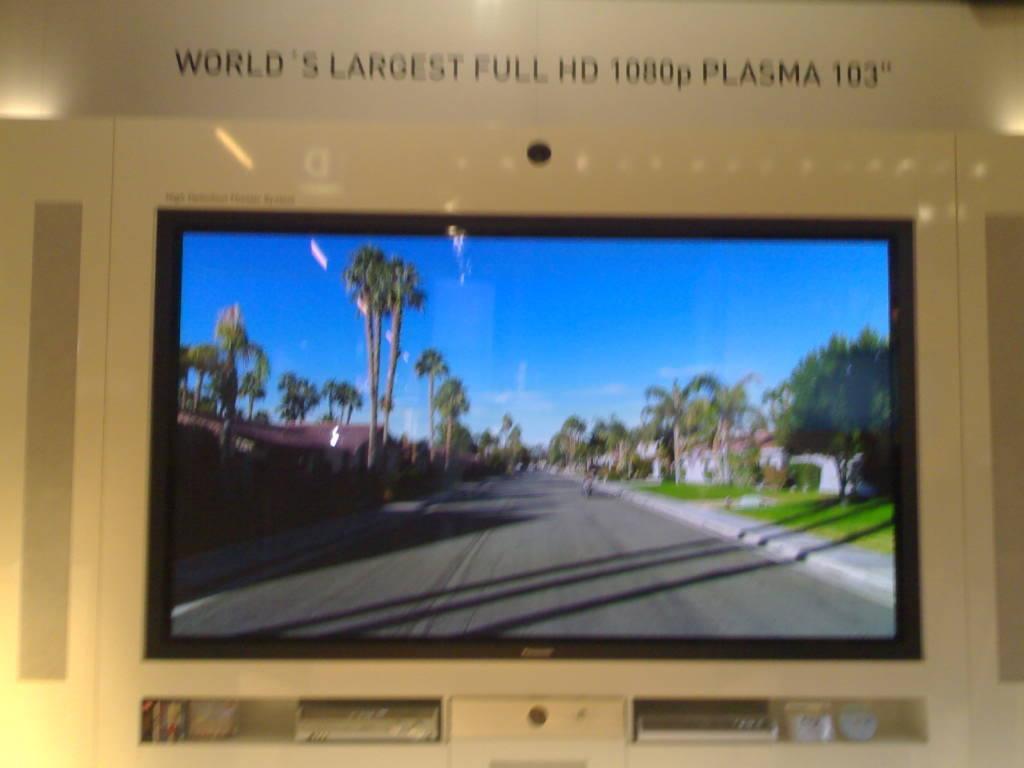What size is the tv?
Offer a very short reply. 103". 